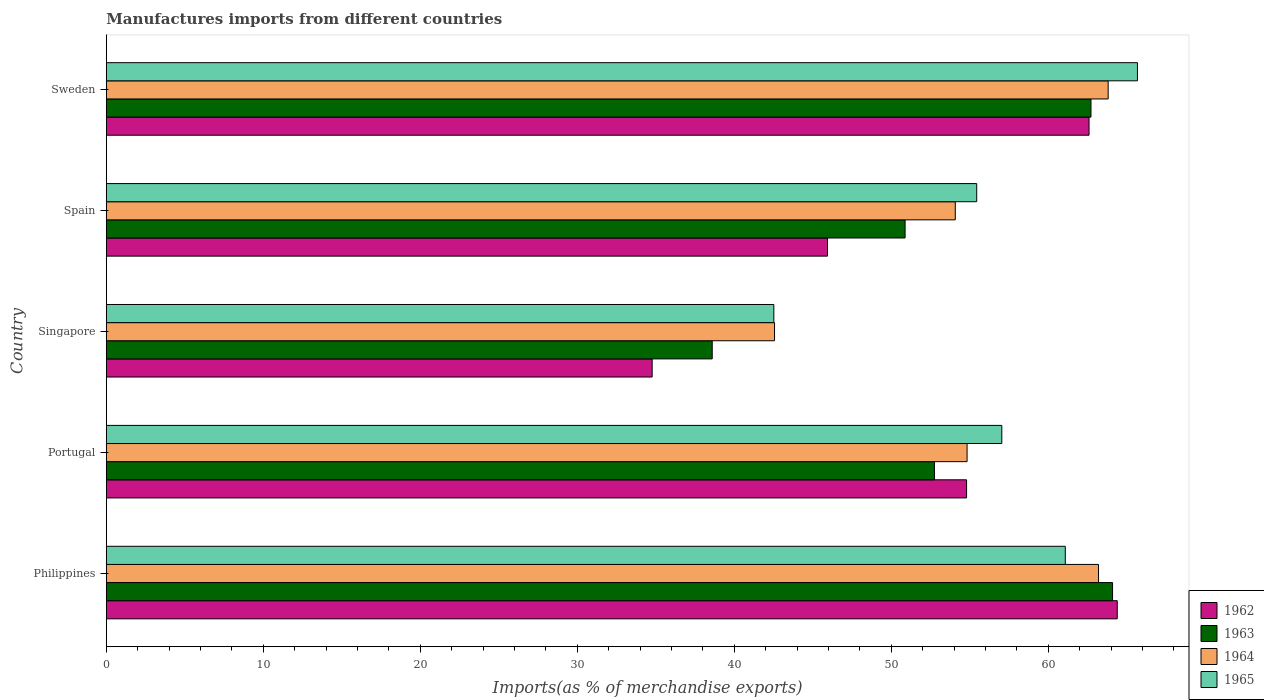Are the number of bars on each tick of the Y-axis equal?
Make the answer very short. Yes. What is the percentage of imports to different countries in 1963 in Portugal?
Give a very brief answer. 52.75. Across all countries, what is the maximum percentage of imports to different countries in 1964?
Your response must be concise. 63.82. Across all countries, what is the minimum percentage of imports to different countries in 1962?
Keep it short and to the point. 34.77. In which country was the percentage of imports to different countries in 1963 minimum?
Give a very brief answer. Singapore. What is the total percentage of imports to different countries in 1963 in the graph?
Ensure brevity in your answer.  269.05. What is the difference between the percentage of imports to different countries in 1965 in Portugal and that in Spain?
Give a very brief answer. 1.6. What is the difference between the percentage of imports to different countries in 1964 in Sweden and the percentage of imports to different countries in 1962 in Spain?
Make the answer very short. 17.88. What is the average percentage of imports to different countries in 1963 per country?
Make the answer very short. 53.81. What is the difference between the percentage of imports to different countries in 1964 and percentage of imports to different countries in 1962 in Sweden?
Offer a terse response. 1.22. What is the ratio of the percentage of imports to different countries in 1965 in Portugal to that in Spain?
Your answer should be compact. 1.03. What is the difference between the highest and the second highest percentage of imports to different countries in 1963?
Give a very brief answer. 1.37. What is the difference between the highest and the lowest percentage of imports to different countries in 1965?
Your answer should be very brief. 23.16. Is it the case that in every country, the sum of the percentage of imports to different countries in 1964 and percentage of imports to different countries in 1965 is greater than the sum of percentage of imports to different countries in 1962 and percentage of imports to different countries in 1963?
Provide a succinct answer. No. What does the 1st bar from the top in Spain represents?
Your answer should be very brief. 1965. What does the 3rd bar from the bottom in Portugal represents?
Provide a succinct answer. 1964. Is it the case that in every country, the sum of the percentage of imports to different countries in 1962 and percentage of imports to different countries in 1964 is greater than the percentage of imports to different countries in 1963?
Your answer should be compact. Yes. Are all the bars in the graph horizontal?
Ensure brevity in your answer.  Yes. What is the difference between two consecutive major ticks on the X-axis?
Provide a short and direct response. 10. Where does the legend appear in the graph?
Your response must be concise. Bottom right. How many legend labels are there?
Your answer should be very brief. 4. What is the title of the graph?
Offer a very short reply. Manufactures imports from different countries. Does "2011" appear as one of the legend labels in the graph?
Provide a short and direct response. No. What is the label or title of the X-axis?
Give a very brief answer. Imports(as % of merchandise exports). What is the Imports(as % of merchandise exports) of 1962 in Philippines?
Keep it short and to the point. 64.4. What is the Imports(as % of merchandise exports) of 1963 in Philippines?
Offer a terse response. 64.1. What is the Imports(as % of merchandise exports) of 1964 in Philippines?
Offer a very short reply. 63.2. What is the Imports(as % of merchandise exports) of 1965 in Philippines?
Your answer should be compact. 61.09. What is the Imports(as % of merchandise exports) in 1962 in Portugal?
Your answer should be very brief. 54.8. What is the Imports(as % of merchandise exports) of 1963 in Portugal?
Ensure brevity in your answer.  52.75. What is the Imports(as % of merchandise exports) in 1964 in Portugal?
Offer a terse response. 54.83. What is the Imports(as % of merchandise exports) of 1965 in Portugal?
Provide a succinct answer. 57.04. What is the Imports(as % of merchandise exports) in 1962 in Singapore?
Your answer should be very brief. 34.77. What is the Imports(as % of merchandise exports) of 1963 in Singapore?
Provide a short and direct response. 38.6. What is the Imports(as % of merchandise exports) of 1964 in Singapore?
Ensure brevity in your answer.  42.56. What is the Imports(as % of merchandise exports) in 1965 in Singapore?
Keep it short and to the point. 42.52. What is the Imports(as % of merchandise exports) of 1962 in Spain?
Your response must be concise. 45.94. What is the Imports(as % of merchandise exports) of 1963 in Spain?
Ensure brevity in your answer.  50.88. What is the Imports(as % of merchandise exports) in 1964 in Spain?
Provide a succinct answer. 54.08. What is the Imports(as % of merchandise exports) of 1965 in Spain?
Your answer should be compact. 55.44. What is the Imports(as % of merchandise exports) of 1962 in Sweden?
Your answer should be compact. 62.6. What is the Imports(as % of merchandise exports) of 1963 in Sweden?
Your answer should be very brief. 62.72. What is the Imports(as % of merchandise exports) in 1964 in Sweden?
Make the answer very short. 63.82. What is the Imports(as % of merchandise exports) of 1965 in Sweden?
Give a very brief answer. 65.68. Across all countries, what is the maximum Imports(as % of merchandise exports) of 1962?
Provide a succinct answer. 64.4. Across all countries, what is the maximum Imports(as % of merchandise exports) of 1963?
Your response must be concise. 64.1. Across all countries, what is the maximum Imports(as % of merchandise exports) in 1964?
Ensure brevity in your answer.  63.82. Across all countries, what is the maximum Imports(as % of merchandise exports) in 1965?
Keep it short and to the point. 65.68. Across all countries, what is the minimum Imports(as % of merchandise exports) of 1962?
Make the answer very short. 34.77. Across all countries, what is the minimum Imports(as % of merchandise exports) of 1963?
Ensure brevity in your answer.  38.6. Across all countries, what is the minimum Imports(as % of merchandise exports) in 1964?
Keep it short and to the point. 42.56. Across all countries, what is the minimum Imports(as % of merchandise exports) in 1965?
Your answer should be compact. 42.52. What is the total Imports(as % of merchandise exports) in 1962 in the graph?
Your answer should be very brief. 262.5. What is the total Imports(as % of merchandise exports) in 1963 in the graph?
Your response must be concise. 269.05. What is the total Imports(as % of merchandise exports) in 1964 in the graph?
Provide a succinct answer. 278.49. What is the total Imports(as % of merchandise exports) in 1965 in the graph?
Your answer should be compact. 281.78. What is the difference between the Imports(as % of merchandise exports) in 1962 in Philippines and that in Portugal?
Offer a terse response. 9.6. What is the difference between the Imports(as % of merchandise exports) in 1963 in Philippines and that in Portugal?
Your response must be concise. 11.35. What is the difference between the Imports(as % of merchandise exports) in 1964 in Philippines and that in Portugal?
Your response must be concise. 8.37. What is the difference between the Imports(as % of merchandise exports) in 1965 in Philippines and that in Portugal?
Provide a short and direct response. 4.04. What is the difference between the Imports(as % of merchandise exports) of 1962 in Philippines and that in Singapore?
Make the answer very short. 29.63. What is the difference between the Imports(as % of merchandise exports) of 1963 in Philippines and that in Singapore?
Your answer should be very brief. 25.5. What is the difference between the Imports(as % of merchandise exports) in 1964 in Philippines and that in Singapore?
Your answer should be compact. 20.64. What is the difference between the Imports(as % of merchandise exports) in 1965 in Philippines and that in Singapore?
Your answer should be very brief. 18.57. What is the difference between the Imports(as % of merchandise exports) of 1962 in Philippines and that in Spain?
Keep it short and to the point. 18.46. What is the difference between the Imports(as % of merchandise exports) of 1963 in Philippines and that in Spain?
Your answer should be very brief. 13.22. What is the difference between the Imports(as % of merchandise exports) of 1964 in Philippines and that in Spain?
Offer a very short reply. 9.12. What is the difference between the Imports(as % of merchandise exports) of 1965 in Philippines and that in Spain?
Offer a terse response. 5.64. What is the difference between the Imports(as % of merchandise exports) in 1962 in Philippines and that in Sweden?
Ensure brevity in your answer.  1.8. What is the difference between the Imports(as % of merchandise exports) of 1963 in Philippines and that in Sweden?
Make the answer very short. 1.37. What is the difference between the Imports(as % of merchandise exports) of 1964 in Philippines and that in Sweden?
Provide a short and direct response. -0.61. What is the difference between the Imports(as % of merchandise exports) of 1965 in Philippines and that in Sweden?
Your answer should be very brief. -4.6. What is the difference between the Imports(as % of merchandise exports) in 1962 in Portugal and that in Singapore?
Provide a succinct answer. 20.03. What is the difference between the Imports(as % of merchandise exports) in 1963 in Portugal and that in Singapore?
Keep it short and to the point. 14.16. What is the difference between the Imports(as % of merchandise exports) in 1964 in Portugal and that in Singapore?
Keep it short and to the point. 12.27. What is the difference between the Imports(as % of merchandise exports) of 1965 in Portugal and that in Singapore?
Provide a succinct answer. 14.52. What is the difference between the Imports(as % of merchandise exports) of 1962 in Portugal and that in Spain?
Provide a succinct answer. 8.86. What is the difference between the Imports(as % of merchandise exports) of 1963 in Portugal and that in Spain?
Your response must be concise. 1.87. What is the difference between the Imports(as % of merchandise exports) of 1964 in Portugal and that in Spain?
Ensure brevity in your answer.  0.75. What is the difference between the Imports(as % of merchandise exports) in 1965 in Portugal and that in Spain?
Provide a succinct answer. 1.6. What is the difference between the Imports(as % of merchandise exports) of 1962 in Portugal and that in Sweden?
Keep it short and to the point. -7.8. What is the difference between the Imports(as % of merchandise exports) of 1963 in Portugal and that in Sweden?
Offer a very short reply. -9.97. What is the difference between the Imports(as % of merchandise exports) of 1964 in Portugal and that in Sweden?
Offer a very short reply. -8.99. What is the difference between the Imports(as % of merchandise exports) in 1965 in Portugal and that in Sweden?
Keep it short and to the point. -8.64. What is the difference between the Imports(as % of merchandise exports) in 1962 in Singapore and that in Spain?
Offer a very short reply. -11.17. What is the difference between the Imports(as % of merchandise exports) in 1963 in Singapore and that in Spain?
Provide a short and direct response. -12.29. What is the difference between the Imports(as % of merchandise exports) in 1964 in Singapore and that in Spain?
Your answer should be very brief. -11.51. What is the difference between the Imports(as % of merchandise exports) of 1965 in Singapore and that in Spain?
Offer a very short reply. -12.92. What is the difference between the Imports(as % of merchandise exports) in 1962 in Singapore and that in Sweden?
Offer a very short reply. -27.83. What is the difference between the Imports(as % of merchandise exports) of 1963 in Singapore and that in Sweden?
Your answer should be compact. -24.13. What is the difference between the Imports(as % of merchandise exports) of 1964 in Singapore and that in Sweden?
Your response must be concise. -21.25. What is the difference between the Imports(as % of merchandise exports) of 1965 in Singapore and that in Sweden?
Offer a terse response. -23.16. What is the difference between the Imports(as % of merchandise exports) of 1962 in Spain and that in Sweden?
Ensure brevity in your answer.  -16.66. What is the difference between the Imports(as % of merchandise exports) in 1963 in Spain and that in Sweden?
Ensure brevity in your answer.  -11.84. What is the difference between the Imports(as % of merchandise exports) in 1964 in Spain and that in Sweden?
Make the answer very short. -9.74. What is the difference between the Imports(as % of merchandise exports) of 1965 in Spain and that in Sweden?
Your answer should be compact. -10.24. What is the difference between the Imports(as % of merchandise exports) of 1962 in Philippines and the Imports(as % of merchandise exports) of 1963 in Portugal?
Keep it short and to the point. 11.65. What is the difference between the Imports(as % of merchandise exports) of 1962 in Philippines and the Imports(as % of merchandise exports) of 1964 in Portugal?
Make the answer very short. 9.57. What is the difference between the Imports(as % of merchandise exports) in 1962 in Philippines and the Imports(as % of merchandise exports) in 1965 in Portugal?
Keep it short and to the point. 7.35. What is the difference between the Imports(as % of merchandise exports) of 1963 in Philippines and the Imports(as % of merchandise exports) of 1964 in Portugal?
Your response must be concise. 9.27. What is the difference between the Imports(as % of merchandise exports) in 1963 in Philippines and the Imports(as % of merchandise exports) in 1965 in Portugal?
Ensure brevity in your answer.  7.05. What is the difference between the Imports(as % of merchandise exports) in 1964 in Philippines and the Imports(as % of merchandise exports) in 1965 in Portugal?
Offer a very short reply. 6.16. What is the difference between the Imports(as % of merchandise exports) in 1962 in Philippines and the Imports(as % of merchandise exports) in 1963 in Singapore?
Keep it short and to the point. 25.8. What is the difference between the Imports(as % of merchandise exports) of 1962 in Philippines and the Imports(as % of merchandise exports) of 1964 in Singapore?
Your answer should be compact. 21.83. What is the difference between the Imports(as % of merchandise exports) of 1962 in Philippines and the Imports(as % of merchandise exports) of 1965 in Singapore?
Ensure brevity in your answer.  21.87. What is the difference between the Imports(as % of merchandise exports) in 1963 in Philippines and the Imports(as % of merchandise exports) in 1964 in Singapore?
Give a very brief answer. 21.53. What is the difference between the Imports(as % of merchandise exports) in 1963 in Philippines and the Imports(as % of merchandise exports) in 1965 in Singapore?
Provide a succinct answer. 21.58. What is the difference between the Imports(as % of merchandise exports) in 1964 in Philippines and the Imports(as % of merchandise exports) in 1965 in Singapore?
Offer a very short reply. 20.68. What is the difference between the Imports(as % of merchandise exports) of 1962 in Philippines and the Imports(as % of merchandise exports) of 1963 in Spain?
Give a very brief answer. 13.51. What is the difference between the Imports(as % of merchandise exports) in 1962 in Philippines and the Imports(as % of merchandise exports) in 1964 in Spain?
Your response must be concise. 10.32. What is the difference between the Imports(as % of merchandise exports) in 1962 in Philippines and the Imports(as % of merchandise exports) in 1965 in Spain?
Ensure brevity in your answer.  8.95. What is the difference between the Imports(as % of merchandise exports) of 1963 in Philippines and the Imports(as % of merchandise exports) of 1964 in Spain?
Your answer should be very brief. 10.02. What is the difference between the Imports(as % of merchandise exports) of 1963 in Philippines and the Imports(as % of merchandise exports) of 1965 in Spain?
Your response must be concise. 8.65. What is the difference between the Imports(as % of merchandise exports) of 1964 in Philippines and the Imports(as % of merchandise exports) of 1965 in Spain?
Give a very brief answer. 7.76. What is the difference between the Imports(as % of merchandise exports) of 1962 in Philippines and the Imports(as % of merchandise exports) of 1963 in Sweden?
Offer a terse response. 1.67. What is the difference between the Imports(as % of merchandise exports) in 1962 in Philippines and the Imports(as % of merchandise exports) in 1964 in Sweden?
Give a very brief answer. 0.58. What is the difference between the Imports(as % of merchandise exports) in 1962 in Philippines and the Imports(as % of merchandise exports) in 1965 in Sweden?
Keep it short and to the point. -1.29. What is the difference between the Imports(as % of merchandise exports) in 1963 in Philippines and the Imports(as % of merchandise exports) in 1964 in Sweden?
Your answer should be very brief. 0.28. What is the difference between the Imports(as % of merchandise exports) of 1963 in Philippines and the Imports(as % of merchandise exports) of 1965 in Sweden?
Keep it short and to the point. -1.58. What is the difference between the Imports(as % of merchandise exports) of 1964 in Philippines and the Imports(as % of merchandise exports) of 1965 in Sweden?
Make the answer very short. -2.48. What is the difference between the Imports(as % of merchandise exports) in 1962 in Portugal and the Imports(as % of merchandise exports) in 1963 in Singapore?
Keep it short and to the point. 16.2. What is the difference between the Imports(as % of merchandise exports) in 1962 in Portugal and the Imports(as % of merchandise exports) in 1964 in Singapore?
Ensure brevity in your answer.  12.23. What is the difference between the Imports(as % of merchandise exports) in 1962 in Portugal and the Imports(as % of merchandise exports) in 1965 in Singapore?
Your answer should be compact. 12.28. What is the difference between the Imports(as % of merchandise exports) in 1963 in Portugal and the Imports(as % of merchandise exports) in 1964 in Singapore?
Offer a very short reply. 10.19. What is the difference between the Imports(as % of merchandise exports) of 1963 in Portugal and the Imports(as % of merchandise exports) of 1965 in Singapore?
Your response must be concise. 10.23. What is the difference between the Imports(as % of merchandise exports) in 1964 in Portugal and the Imports(as % of merchandise exports) in 1965 in Singapore?
Your response must be concise. 12.31. What is the difference between the Imports(as % of merchandise exports) in 1962 in Portugal and the Imports(as % of merchandise exports) in 1963 in Spain?
Make the answer very short. 3.92. What is the difference between the Imports(as % of merchandise exports) of 1962 in Portugal and the Imports(as % of merchandise exports) of 1964 in Spain?
Keep it short and to the point. 0.72. What is the difference between the Imports(as % of merchandise exports) in 1962 in Portugal and the Imports(as % of merchandise exports) in 1965 in Spain?
Provide a succinct answer. -0.65. What is the difference between the Imports(as % of merchandise exports) of 1963 in Portugal and the Imports(as % of merchandise exports) of 1964 in Spain?
Your answer should be compact. -1.33. What is the difference between the Imports(as % of merchandise exports) of 1963 in Portugal and the Imports(as % of merchandise exports) of 1965 in Spain?
Provide a succinct answer. -2.69. What is the difference between the Imports(as % of merchandise exports) of 1964 in Portugal and the Imports(as % of merchandise exports) of 1965 in Spain?
Your response must be concise. -0.61. What is the difference between the Imports(as % of merchandise exports) of 1962 in Portugal and the Imports(as % of merchandise exports) of 1963 in Sweden?
Make the answer very short. -7.92. What is the difference between the Imports(as % of merchandise exports) of 1962 in Portugal and the Imports(as % of merchandise exports) of 1964 in Sweden?
Ensure brevity in your answer.  -9.02. What is the difference between the Imports(as % of merchandise exports) of 1962 in Portugal and the Imports(as % of merchandise exports) of 1965 in Sweden?
Your answer should be compact. -10.88. What is the difference between the Imports(as % of merchandise exports) in 1963 in Portugal and the Imports(as % of merchandise exports) in 1964 in Sweden?
Provide a succinct answer. -11.07. What is the difference between the Imports(as % of merchandise exports) of 1963 in Portugal and the Imports(as % of merchandise exports) of 1965 in Sweden?
Your response must be concise. -12.93. What is the difference between the Imports(as % of merchandise exports) in 1964 in Portugal and the Imports(as % of merchandise exports) in 1965 in Sweden?
Provide a succinct answer. -10.85. What is the difference between the Imports(as % of merchandise exports) in 1962 in Singapore and the Imports(as % of merchandise exports) in 1963 in Spain?
Your response must be concise. -16.11. What is the difference between the Imports(as % of merchandise exports) of 1962 in Singapore and the Imports(as % of merchandise exports) of 1964 in Spain?
Make the answer very short. -19.31. What is the difference between the Imports(as % of merchandise exports) of 1962 in Singapore and the Imports(as % of merchandise exports) of 1965 in Spain?
Keep it short and to the point. -20.68. What is the difference between the Imports(as % of merchandise exports) of 1963 in Singapore and the Imports(as % of merchandise exports) of 1964 in Spain?
Offer a very short reply. -15.48. What is the difference between the Imports(as % of merchandise exports) in 1963 in Singapore and the Imports(as % of merchandise exports) in 1965 in Spain?
Your response must be concise. -16.85. What is the difference between the Imports(as % of merchandise exports) in 1964 in Singapore and the Imports(as % of merchandise exports) in 1965 in Spain?
Your response must be concise. -12.88. What is the difference between the Imports(as % of merchandise exports) in 1962 in Singapore and the Imports(as % of merchandise exports) in 1963 in Sweden?
Provide a short and direct response. -27.95. What is the difference between the Imports(as % of merchandise exports) in 1962 in Singapore and the Imports(as % of merchandise exports) in 1964 in Sweden?
Provide a succinct answer. -29.05. What is the difference between the Imports(as % of merchandise exports) in 1962 in Singapore and the Imports(as % of merchandise exports) in 1965 in Sweden?
Keep it short and to the point. -30.91. What is the difference between the Imports(as % of merchandise exports) of 1963 in Singapore and the Imports(as % of merchandise exports) of 1964 in Sweden?
Your response must be concise. -25.22. What is the difference between the Imports(as % of merchandise exports) of 1963 in Singapore and the Imports(as % of merchandise exports) of 1965 in Sweden?
Provide a succinct answer. -27.09. What is the difference between the Imports(as % of merchandise exports) in 1964 in Singapore and the Imports(as % of merchandise exports) in 1965 in Sweden?
Offer a terse response. -23.12. What is the difference between the Imports(as % of merchandise exports) of 1962 in Spain and the Imports(as % of merchandise exports) of 1963 in Sweden?
Offer a terse response. -16.78. What is the difference between the Imports(as % of merchandise exports) of 1962 in Spain and the Imports(as % of merchandise exports) of 1964 in Sweden?
Your response must be concise. -17.88. What is the difference between the Imports(as % of merchandise exports) in 1962 in Spain and the Imports(as % of merchandise exports) in 1965 in Sweden?
Offer a terse response. -19.74. What is the difference between the Imports(as % of merchandise exports) of 1963 in Spain and the Imports(as % of merchandise exports) of 1964 in Sweden?
Ensure brevity in your answer.  -12.94. What is the difference between the Imports(as % of merchandise exports) in 1963 in Spain and the Imports(as % of merchandise exports) in 1965 in Sweden?
Offer a terse response. -14.8. What is the difference between the Imports(as % of merchandise exports) in 1964 in Spain and the Imports(as % of merchandise exports) in 1965 in Sweden?
Ensure brevity in your answer.  -11.6. What is the average Imports(as % of merchandise exports) of 1962 per country?
Give a very brief answer. 52.5. What is the average Imports(as % of merchandise exports) in 1963 per country?
Make the answer very short. 53.81. What is the average Imports(as % of merchandise exports) in 1964 per country?
Make the answer very short. 55.7. What is the average Imports(as % of merchandise exports) of 1965 per country?
Keep it short and to the point. 56.36. What is the difference between the Imports(as % of merchandise exports) in 1962 and Imports(as % of merchandise exports) in 1963 in Philippines?
Give a very brief answer. 0.3. What is the difference between the Imports(as % of merchandise exports) in 1962 and Imports(as % of merchandise exports) in 1964 in Philippines?
Your answer should be very brief. 1.19. What is the difference between the Imports(as % of merchandise exports) in 1962 and Imports(as % of merchandise exports) in 1965 in Philippines?
Make the answer very short. 3.31. What is the difference between the Imports(as % of merchandise exports) of 1963 and Imports(as % of merchandise exports) of 1964 in Philippines?
Provide a succinct answer. 0.89. What is the difference between the Imports(as % of merchandise exports) of 1963 and Imports(as % of merchandise exports) of 1965 in Philippines?
Ensure brevity in your answer.  3.01. What is the difference between the Imports(as % of merchandise exports) of 1964 and Imports(as % of merchandise exports) of 1965 in Philippines?
Offer a terse response. 2.12. What is the difference between the Imports(as % of merchandise exports) of 1962 and Imports(as % of merchandise exports) of 1963 in Portugal?
Keep it short and to the point. 2.05. What is the difference between the Imports(as % of merchandise exports) of 1962 and Imports(as % of merchandise exports) of 1964 in Portugal?
Your answer should be very brief. -0.03. What is the difference between the Imports(as % of merchandise exports) of 1962 and Imports(as % of merchandise exports) of 1965 in Portugal?
Your answer should be very brief. -2.24. What is the difference between the Imports(as % of merchandise exports) of 1963 and Imports(as % of merchandise exports) of 1964 in Portugal?
Make the answer very short. -2.08. What is the difference between the Imports(as % of merchandise exports) in 1963 and Imports(as % of merchandise exports) in 1965 in Portugal?
Keep it short and to the point. -4.29. What is the difference between the Imports(as % of merchandise exports) of 1964 and Imports(as % of merchandise exports) of 1965 in Portugal?
Offer a very short reply. -2.21. What is the difference between the Imports(as % of merchandise exports) in 1962 and Imports(as % of merchandise exports) in 1963 in Singapore?
Your answer should be very brief. -3.83. What is the difference between the Imports(as % of merchandise exports) of 1962 and Imports(as % of merchandise exports) of 1964 in Singapore?
Provide a short and direct response. -7.8. What is the difference between the Imports(as % of merchandise exports) of 1962 and Imports(as % of merchandise exports) of 1965 in Singapore?
Offer a very short reply. -7.75. What is the difference between the Imports(as % of merchandise exports) in 1963 and Imports(as % of merchandise exports) in 1964 in Singapore?
Your response must be concise. -3.97. What is the difference between the Imports(as % of merchandise exports) of 1963 and Imports(as % of merchandise exports) of 1965 in Singapore?
Keep it short and to the point. -3.93. What is the difference between the Imports(as % of merchandise exports) of 1964 and Imports(as % of merchandise exports) of 1965 in Singapore?
Make the answer very short. 0.04. What is the difference between the Imports(as % of merchandise exports) in 1962 and Imports(as % of merchandise exports) in 1963 in Spain?
Offer a very short reply. -4.94. What is the difference between the Imports(as % of merchandise exports) of 1962 and Imports(as % of merchandise exports) of 1964 in Spain?
Your answer should be compact. -8.14. What is the difference between the Imports(as % of merchandise exports) in 1962 and Imports(as % of merchandise exports) in 1965 in Spain?
Your answer should be compact. -9.51. What is the difference between the Imports(as % of merchandise exports) of 1963 and Imports(as % of merchandise exports) of 1964 in Spain?
Give a very brief answer. -3.2. What is the difference between the Imports(as % of merchandise exports) of 1963 and Imports(as % of merchandise exports) of 1965 in Spain?
Make the answer very short. -4.56. What is the difference between the Imports(as % of merchandise exports) in 1964 and Imports(as % of merchandise exports) in 1965 in Spain?
Ensure brevity in your answer.  -1.37. What is the difference between the Imports(as % of merchandise exports) of 1962 and Imports(as % of merchandise exports) of 1963 in Sweden?
Ensure brevity in your answer.  -0.12. What is the difference between the Imports(as % of merchandise exports) in 1962 and Imports(as % of merchandise exports) in 1964 in Sweden?
Offer a terse response. -1.22. What is the difference between the Imports(as % of merchandise exports) in 1962 and Imports(as % of merchandise exports) in 1965 in Sweden?
Give a very brief answer. -3.08. What is the difference between the Imports(as % of merchandise exports) in 1963 and Imports(as % of merchandise exports) in 1964 in Sweden?
Offer a terse response. -1.09. What is the difference between the Imports(as % of merchandise exports) in 1963 and Imports(as % of merchandise exports) in 1965 in Sweden?
Keep it short and to the point. -2.96. What is the difference between the Imports(as % of merchandise exports) of 1964 and Imports(as % of merchandise exports) of 1965 in Sweden?
Provide a succinct answer. -1.87. What is the ratio of the Imports(as % of merchandise exports) in 1962 in Philippines to that in Portugal?
Provide a short and direct response. 1.18. What is the ratio of the Imports(as % of merchandise exports) in 1963 in Philippines to that in Portugal?
Keep it short and to the point. 1.22. What is the ratio of the Imports(as % of merchandise exports) in 1964 in Philippines to that in Portugal?
Keep it short and to the point. 1.15. What is the ratio of the Imports(as % of merchandise exports) of 1965 in Philippines to that in Portugal?
Keep it short and to the point. 1.07. What is the ratio of the Imports(as % of merchandise exports) of 1962 in Philippines to that in Singapore?
Provide a succinct answer. 1.85. What is the ratio of the Imports(as % of merchandise exports) of 1963 in Philippines to that in Singapore?
Keep it short and to the point. 1.66. What is the ratio of the Imports(as % of merchandise exports) of 1964 in Philippines to that in Singapore?
Provide a succinct answer. 1.48. What is the ratio of the Imports(as % of merchandise exports) of 1965 in Philippines to that in Singapore?
Offer a terse response. 1.44. What is the ratio of the Imports(as % of merchandise exports) of 1962 in Philippines to that in Spain?
Provide a short and direct response. 1.4. What is the ratio of the Imports(as % of merchandise exports) of 1963 in Philippines to that in Spain?
Offer a terse response. 1.26. What is the ratio of the Imports(as % of merchandise exports) of 1964 in Philippines to that in Spain?
Make the answer very short. 1.17. What is the ratio of the Imports(as % of merchandise exports) of 1965 in Philippines to that in Spain?
Provide a short and direct response. 1.1. What is the ratio of the Imports(as % of merchandise exports) of 1962 in Philippines to that in Sweden?
Give a very brief answer. 1.03. What is the ratio of the Imports(as % of merchandise exports) in 1963 in Philippines to that in Sweden?
Keep it short and to the point. 1.02. What is the ratio of the Imports(as % of merchandise exports) of 1964 in Philippines to that in Sweden?
Your answer should be compact. 0.99. What is the ratio of the Imports(as % of merchandise exports) of 1962 in Portugal to that in Singapore?
Your answer should be very brief. 1.58. What is the ratio of the Imports(as % of merchandise exports) of 1963 in Portugal to that in Singapore?
Ensure brevity in your answer.  1.37. What is the ratio of the Imports(as % of merchandise exports) of 1964 in Portugal to that in Singapore?
Your answer should be very brief. 1.29. What is the ratio of the Imports(as % of merchandise exports) of 1965 in Portugal to that in Singapore?
Give a very brief answer. 1.34. What is the ratio of the Imports(as % of merchandise exports) in 1962 in Portugal to that in Spain?
Provide a short and direct response. 1.19. What is the ratio of the Imports(as % of merchandise exports) in 1963 in Portugal to that in Spain?
Your answer should be compact. 1.04. What is the ratio of the Imports(as % of merchandise exports) of 1964 in Portugal to that in Spain?
Your answer should be compact. 1.01. What is the ratio of the Imports(as % of merchandise exports) in 1965 in Portugal to that in Spain?
Provide a succinct answer. 1.03. What is the ratio of the Imports(as % of merchandise exports) of 1962 in Portugal to that in Sweden?
Make the answer very short. 0.88. What is the ratio of the Imports(as % of merchandise exports) in 1963 in Portugal to that in Sweden?
Keep it short and to the point. 0.84. What is the ratio of the Imports(as % of merchandise exports) in 1964 in Portugal to that in Sweden?
Offer a very short reply. 0.86. What is the ratio of the Imports(as % of merchandise exports) of 1965 in Portugal to that in Sweden?
Your answer should be very brief. 0.87. What is the ratio of the Imports(as % of merchandise exports) in 1962 in Singapore to that in Spain?
Offer a terse response. 0.76. What is the ratio of the Imports(as % of merchandise exports) of 1963 in Singapore to that in Spain?
Ensure brevity in your answer.  0.76. What is the ratio of the Imports(as % of merchandise exports) of 1964 in Singapore to that in Spain?
Make the answer very short. 0.79. What is the ratio of the Imports(as % of merchandise exports) in 1965 in Singapore to that in Spain?
Give a very brief answer. 0.77. What is the ratio of the Imports(as % of merchandise exports) in 1962 in Singapore to that in Sweden?
Your answer should be compact. 0.56. What is the ratio of the Imports(as % of merchandise exports) of 1963 in Singapore to that in Sweden?
Provide a short and direct response. 0.62. What is the ratio of the Imports(as % of merchandise exports) in 1964 in Singapore to that in Sweden?
Offer a terse response. 0.67. What is the ratio of the Imports(as % of merchandise exports) in 1965 in Singapore to that in Sweden?
Ensure brevity in your answer.  0.65. What is the ratio of the Imports(as % of merchandise exports) in 1962 in Spain to that in Sweden?
Keep it short and to the point. 0.73. What is the ratio of the Imports(as % of merchandise exports) of 1963 in Spain to that in Sweden?
Your answer should be compact. 0.81. What is the ratio of the Imports(as % of merchandise exports) of 1964 in Spain to that in Sweden?
Offer a very short reply. 0.85. What is the ratio of the Imports(as % of merchandise exports) of 1965 in Spain to that in Sweden?
Your response must be concise. 0.84. What is the difference between the highest and the second highest Imports(as % of merchandise exports) in 1962?
Provide a succinct answer. 1.8. What is the difference between the highest and the second highest Imports(as % of merchandise exports) of 1963?
Provide a short and direct response. 1.37. What is the difference between the highest and the second highest Imports(as % of merchandise exports) of 1964?
Offer a terse response. 0.61. What is the difference between the highest and the second highest Imports(as % of merchandise exports) in 1965?
Your answer should be compact. 4.6. What is the difference between the highest and the lowest Imports(as % of merchandise exports) in 1962?
Offer a very short reply. 29.63. What is the difference between the highest and the lowest Imports(as % of merchandise exports) of 1963?
Provide a short and direct response. 25.5. What is the difference between the highest and the lowest Imports(as % of merchandise exports) in 1964?
Offer a very short reply. 21.25. What is the difference between the highest and the lowest Imports(as % of merchandise exports) of 1965?
Provide a short and direct response. 23.16. 